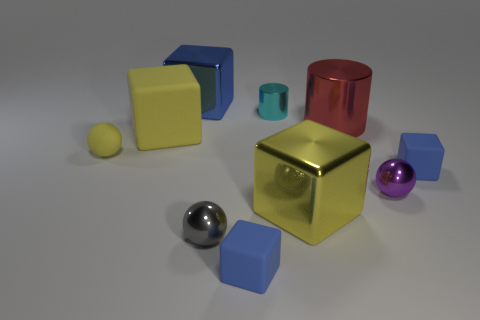The matte block that is the same color as the rubber ball is what size?
Ensure brevity in your answer.  Large. The big yellow metal thing is what shape?
Ensure brevity in your answer.  Cube. What shape is the yellow thing that is in front of the small rubber block that is right of the tiny cyan metallic cylinder?
Ensure brevity in your answer.  Cube. Is the material of the sphere that is behind the tiny purple object the same as the cyan object?
Offer a very short reply. No. What number of cyan objects are either tiny matte cubes or large rubber cylinders?
Provide a succinct answer. 0. Is there a small cube of the same color as the big matte block?
Provide a succinct answer. No. Is there a large purple ball that has the same material as the large red cylinder?
Ensure brevity in your answer.  No. There is a big object that is both in front of the large red cylinder and to the right of the cyan metal thing; what is its shape?
Your answer should be compact. Cube. How many big objects are brown cylinders or metal blocks?
Your response must be concise. 2. What is the material of the large red object?
Make the answer very short. Metal. 